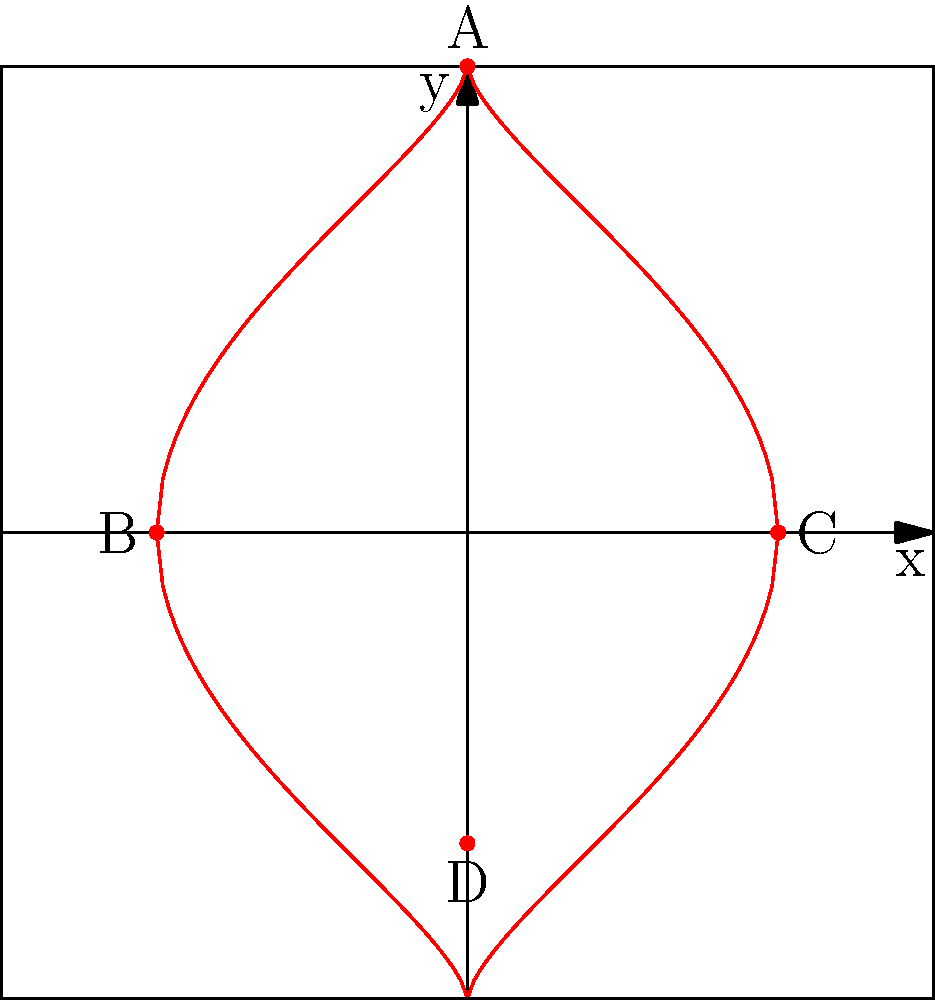Meg wants to create a heart-shaped decoration for Barbara's birthday party. She asks you to help her plot points on a coordinate plane to form a heart shape. Which of the following sets of coordinates correctly represents the key points A, B, C, and D of the heart shape shown in the graph? To determine the correct coordinates for points A, B, C, and D, let's analyze each point:

1. Point A: This point is at the top of the heart shape. Its x-coordinate is 0, and its y-coordinate is 1.5 units above the origin. So, A is at (0, 1.5).

2. Point B: This point is on the left side of the heart, where it intersects the x-axis. Its x-coordinate is -1, and its y-coordinate is 0. So, B is at (-1, 0).

3. Point C: This point is on the right side of the heart, where it intersects the x-axis. Its x-coordinate is 1, and its y-coordinate is 0. So, C is at (1, 0).

4. Point D: This point is at the bottom of the heart shape. Its x-coordinate is 0, and its y-coordinate is 1 unit below the origin. So, D is at (0, -1).

Therefore, the correct set of coordinates for points A, B, C, and D is:
A(0, 1.5), B(-1, 0), C(1, 0), D(0, -1)
Answer: A(0, 1.5), B(-1, 0), C(1, 0), D(0, -1) 